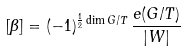<formula> <loc_0><loc_0><loc_500><loc_500>[ \beta ] = ( - 1 ) ^ { \frac { 1 } { 2 } \dim G / T } \, \frac { e ( G / T ) } { | W | }</formula> 